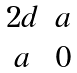Convert formula to latex. <formula><loc_0><loc_0><loc_500><loc_500>\begin{matrix} 2 d & a \\ a & 0 \end{matrix}</formula> 